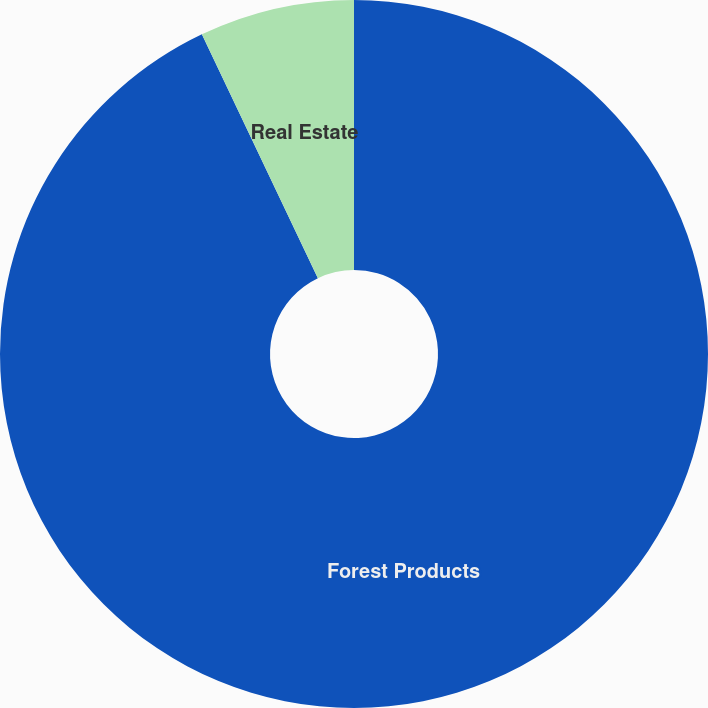Convert chart. <chart><loc_0><loc_0><loc_500><loc_500><pie_chart><fcel>Forest Products<fcel>Real Estate<nl><fcel>92.93%<fcel>7.07%<nl></chart> 